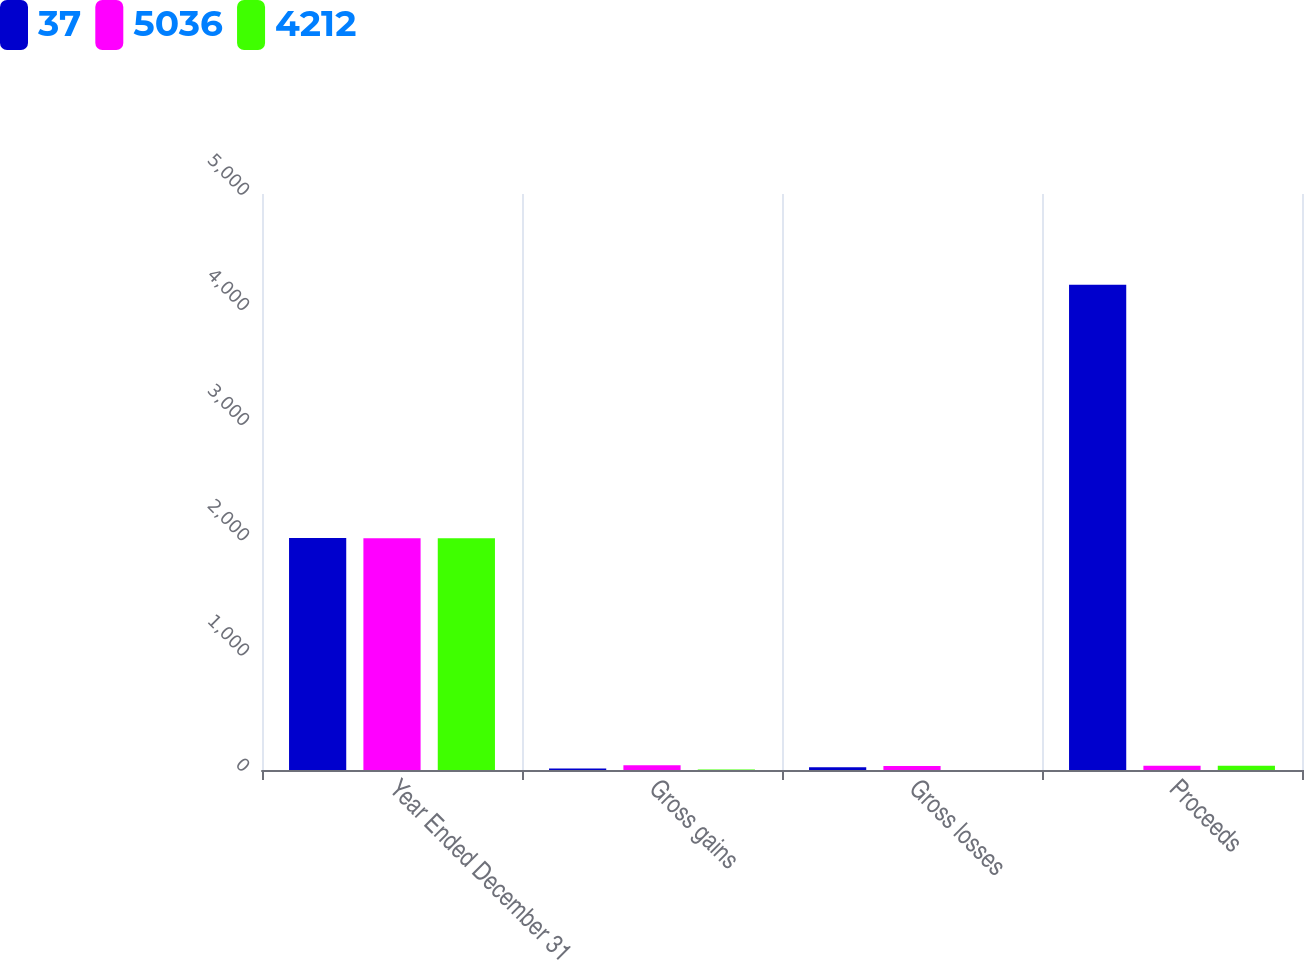Convert chart to OTSL. <chart><loc_0><loc_0><loc_500><loc_500><stacked_bar_chart><ecel><fcel>Year Ended December 31<fcel>Gross gains<fcel>Gross losses<fcel>Proceeds<nl><fcel>37<fcel>2013<fcel>12<fcel>24<fcel>4212<nl><fcel>5036<fcel>2012<fcel>41<fcel>35<fcel>37<nl><fcel>4212<fcel>2011<fcel>5<fcel>1<fcel>37<nl></chart> 